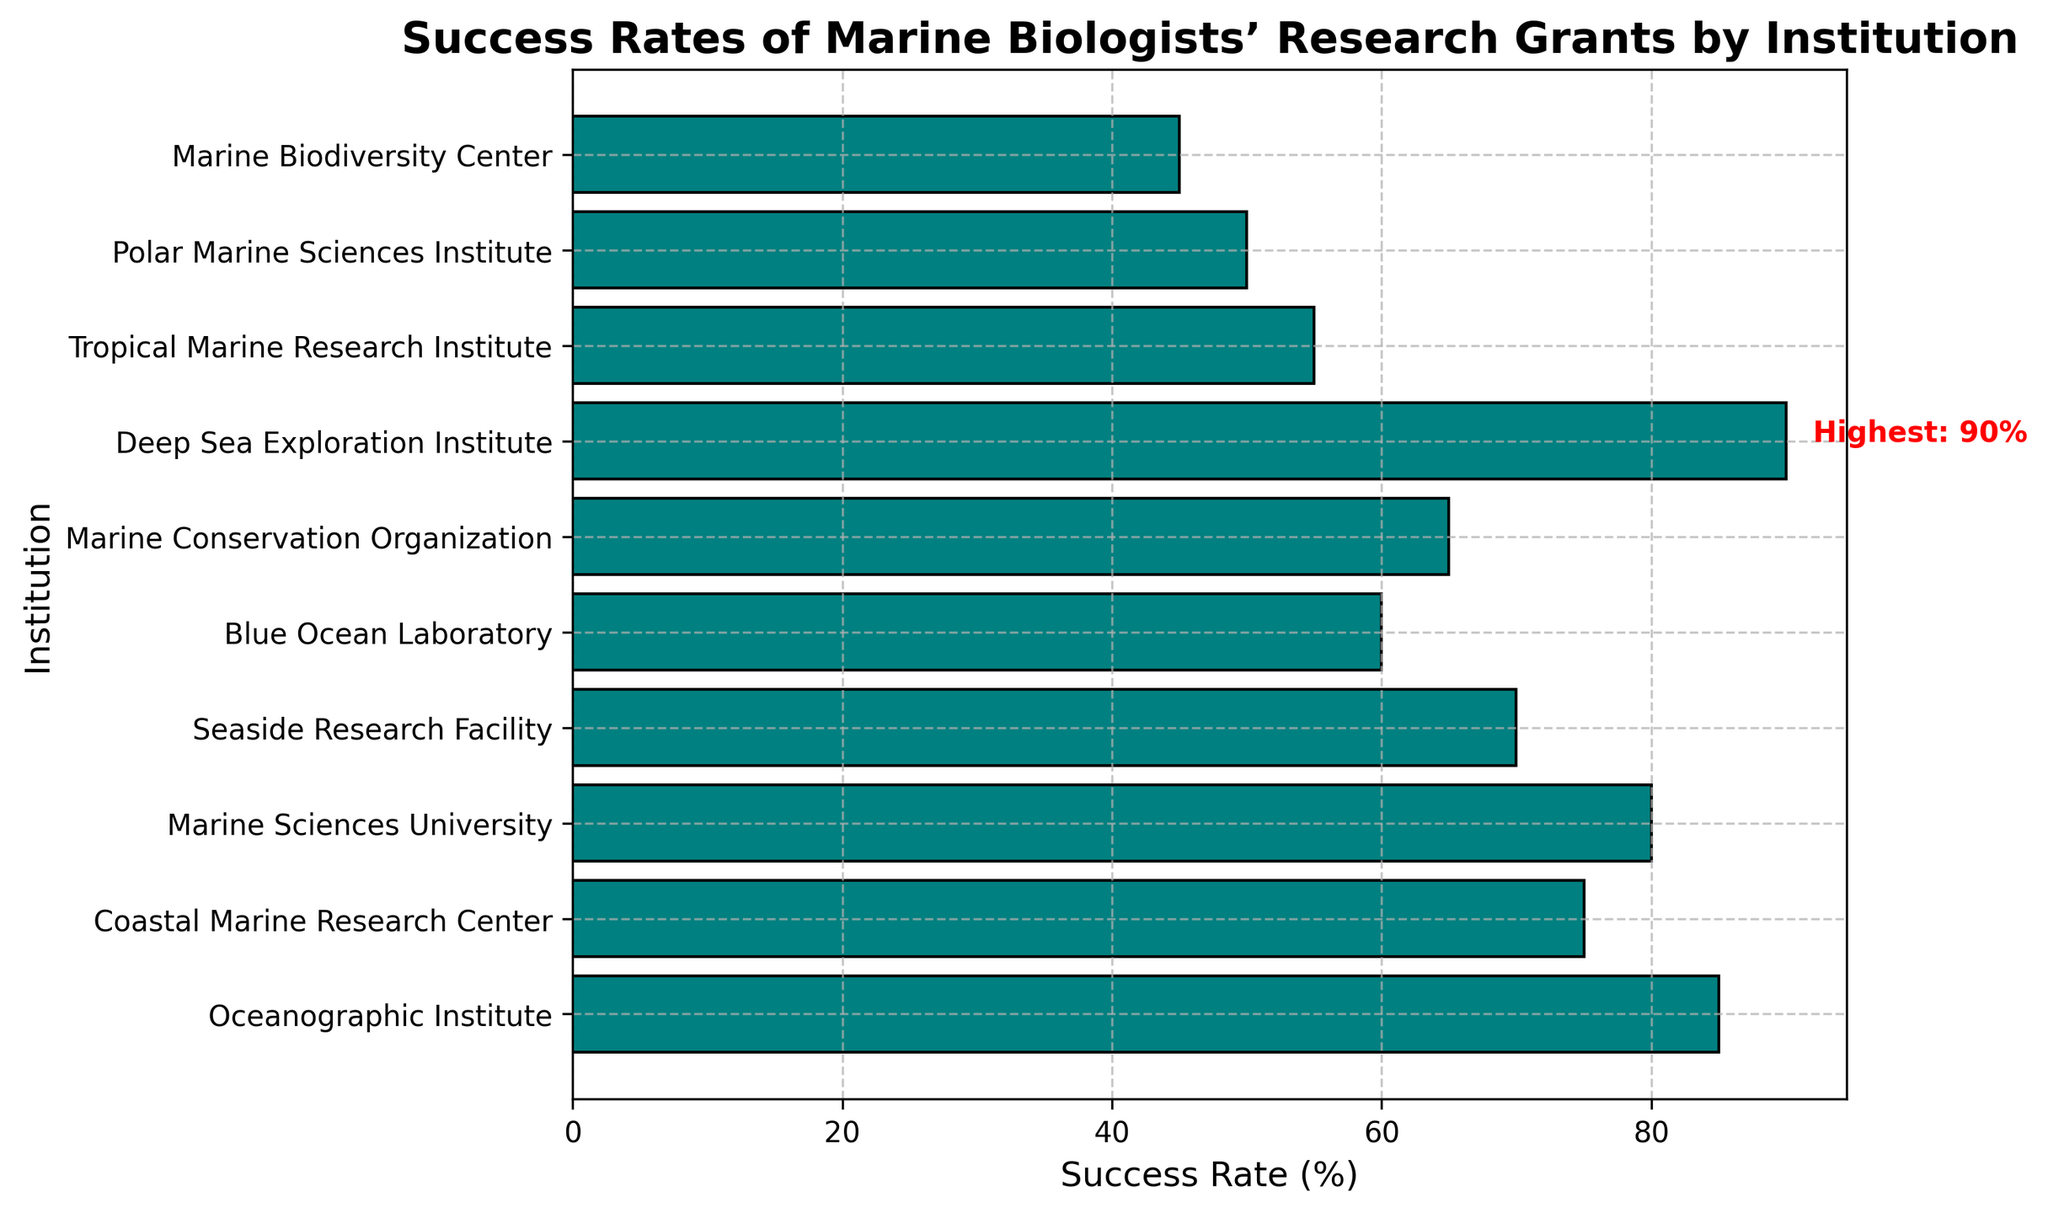Which institution has the highest success rate? The figure has a text annotation pointing out the highest success rate, which is 90% associated with the Deep Sea Exploration Institute.
Answer: Deep Sea Exploration Institute Which institution has a lower success rate than the Oceanographic Institute but higher than the Seaside Research Facility? The Oceanographic Institute has an 85% success rate, and the Seaside Research Facility has a 70% success rate. The success rate that lies between these is 80%, associated with the Marine Sciences University.
Answer: Marine Sciences University What is the difference in success rates between the highest and lowest institutions? The highest success rate is 90% (Deep Sea Exploration Institute), and the lowest is 45% (Marine Biodiversity Center). The difference is 90% - 45%.
Answer: 45% Which institutions have a success rate equal to or above 75%? The institutions with success rates of 75% and above are: Oceanographic Institute (85%), Coastal Marine Research Center (75%), Marine Sciences University (80%), and Deep Sea Exploration Institute (90%).
Answer: Oceanographic Institute, Coastal Marine Research Center, Marine Sciences University, Deep Sea Exploration Institute What is the median success rate across these institutions? To find the median, list the success rates in ascending order: 45, 50, 55, 60, 65, 70, 75, 80, 85, 90. The median is the average of the 5th and 6th value: (65 + 70) / 2.
Answer: 67.5 Which institution has a success rate immediately below the top institution? The top institution is Deep Sea Exploration Institute with 90%. The next highest is Oceanographic Institute with 85%.
Answer: Oceanographic Institute Are there more institutions with a success rate equal to or below 70% or above 70%? Institutions with a success rate equal to or below 70%: Seaside Research Facility (70%), Blue Ocean Laboratory (60%), Marine Conservation Organization (65%), Tropical Marine Research Institute (55%), Polar Marine Sciences Institute (50%), Marine Biodiversity Center (45%) — 6 institutions. Institutions with a success rate above 70%: Oceanographic Institute (85%), Coastal Marine Research Center (75%), Marine Sciences University (80%), Deep Sea Exploration Institute (90%) — 4 institutions. There are more institutions with a success rate equal to or below 70%.
Answer: Equal to or below 70% What is the success rate range of the institutions? The highest success rate is 90% and the lowest is 45%. The range is 90% - 45%.
Answer: 45% What is the average success rate across all institutions? Sum the success rates: 85 + 75 + 80 + 70 + 60 + 65 + 90 + 55 + 50 + 45 = 675. Divide by the number of institutions (10).
Answer: 67.5 